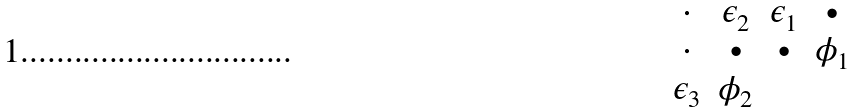<formula> <loc_0><loc_0><loc_500><loc_500>\begin{matrix} \cdot & \epsilon _ { 2 } & \epsilon _ { 1 } & \bullet \\ \cdot & \bullet & \bullet & \phi _ { 1 } \\ \epsilon _ { 3 } & \phi _ { 2 } & & \\ \end{matrix}</formula> 